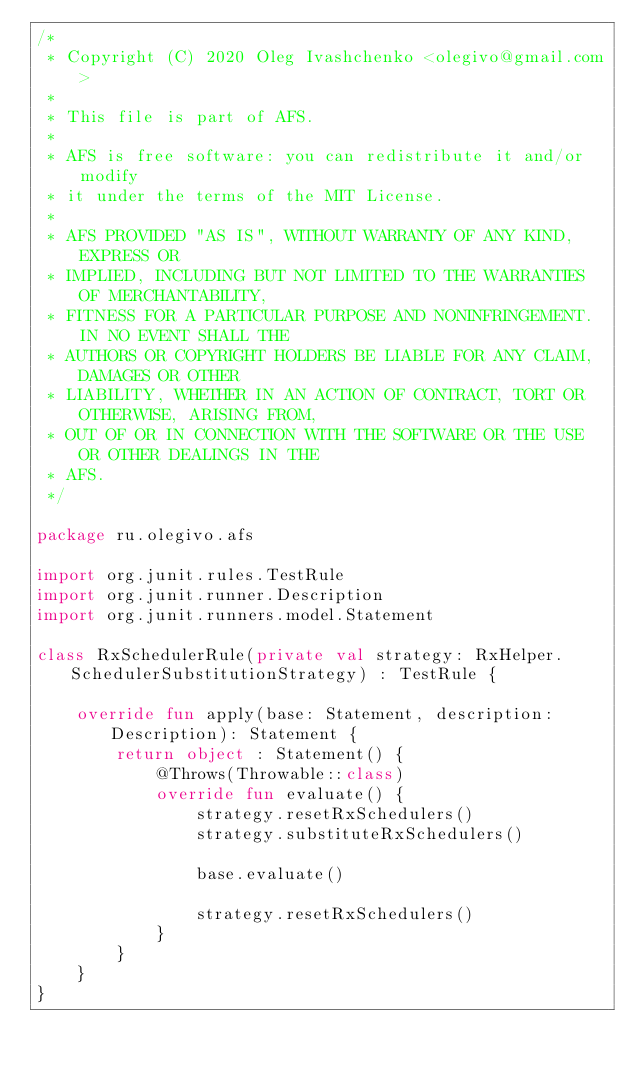<code> <loc_0><loc_0><loc_500><loc_500><_Kotlin_>/*
 * Copyright (C) 2020 Oleg Ivashchenko <olegivo@gmail.com>
 *  
 * This file is part of AFS.
 *
 * AFS is free software: you can redistribute it and/or modify
 * it under the terms of the MIT License.
 *
 * AFS PROVIDED "AS IS", WITHOUT WARRANTY OF ANY KIND, EXPRESS OR
 * IMPLIED, INCLUDING BUT NOT LIMITED TO THE WARRANTIES OF MERCHANTABILITY,
 * FITNESS FOR A PARTICULAR PURPOSE AND NONINFRINGEMENT. IN NO EVENT SHALL THE
 * AUTHORS OR COPYRIGHT HOLDERS BE LIABLE FOR ANY CLAIM, DAMAGES OR OTHER
 * LIABILITY, WHETHER IN AN ACTION OF CONTRACT, TORT OR OTHERWISE, ARISING FROM,
 * OUT OF OR IN CONNECTION WITH THE SOFTWARE OR THE USE OR OTHER DEALINGS IN THE
 * AFS.
 */

package ru.olegivo.afs

import org.junit.rules.TestRule
import org.junit.runner.Description
import org.junit.runners.model.Statement

class RxSchedulerRule(private val strategy: RxHelper.SchedulerSubstitutionStrategy) : TestRule {

    override fun apply(base: Statement, description: Description): Statement {
        return object : Statement() {
            @Throws(Throwable::class)
            override fun evaluate() {
                strategy.resetRxSchedulers()
                strategy.substituteRxSchedulers()

                base.evaluate()

                strategy.resetRxSchedulers()
            }
        }
    }
}
</code> 